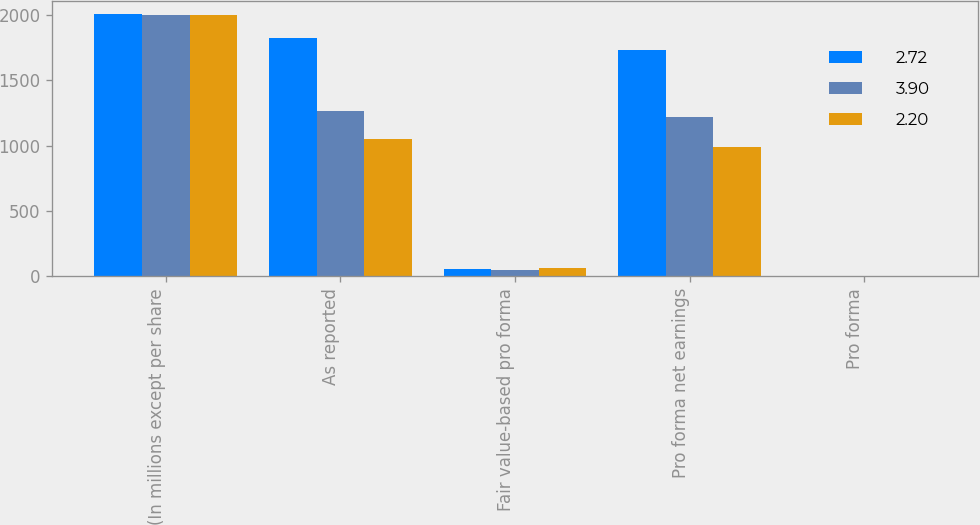Convert chart. <chart><loc_0><loc_0><loc_500><loc_500><stacked_bar_chart><ecel><fcel>(In millions except per share<fcel>As reported<fcel>Fair value-based pro forma<fcel>Pro forma net earnings<fcel>Pro forma<nl><fcel>2.72<fcel>2005<fcel>1825<fcel>56<fcel>1736<fcel>3.95<nl><fcel>3.9<fcel>2004<fcel>1266<fcel>48<fcel>1218<fcel>2.75<nl><fcel>2.2<fcel>2003<fcel>1053<fcel>61<fcel>992<fcel>2.22<nl></chart> 